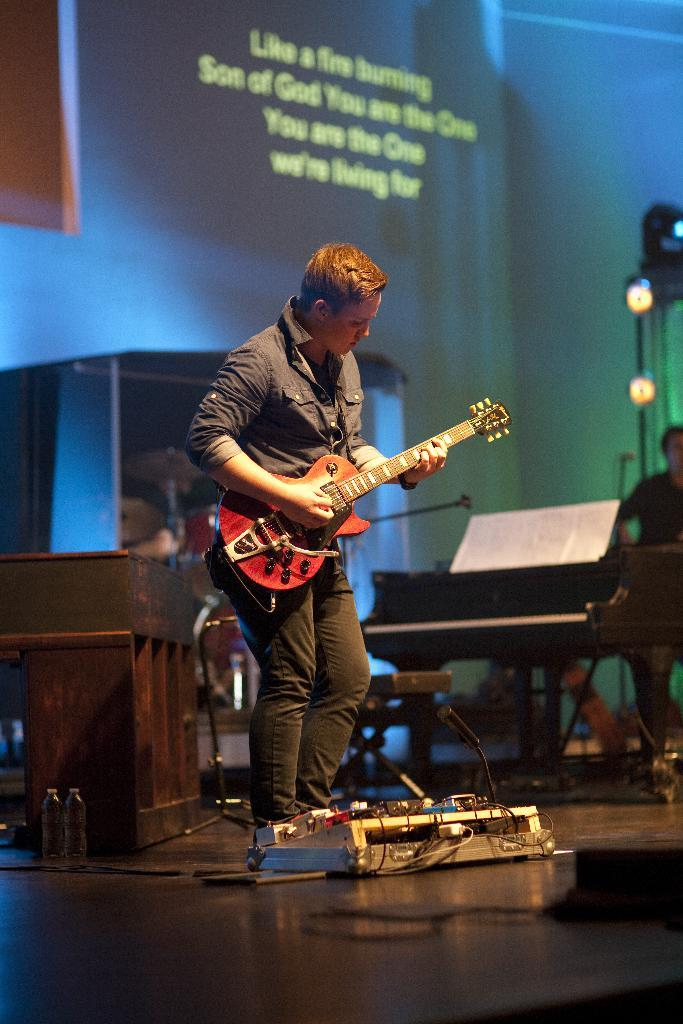What is the person in the image holding? The person is holding a guitar. What can be seen in the background of the image? There is a piano, a screen, and lights in the background of the image. Are there any other people visible in the image? Yes, there is another person standing in the background of the image. What time of day is it in the image, and what is causing the person to cough? The time of day is not mentioned in the image, and there is no indication of anyone coughing. 